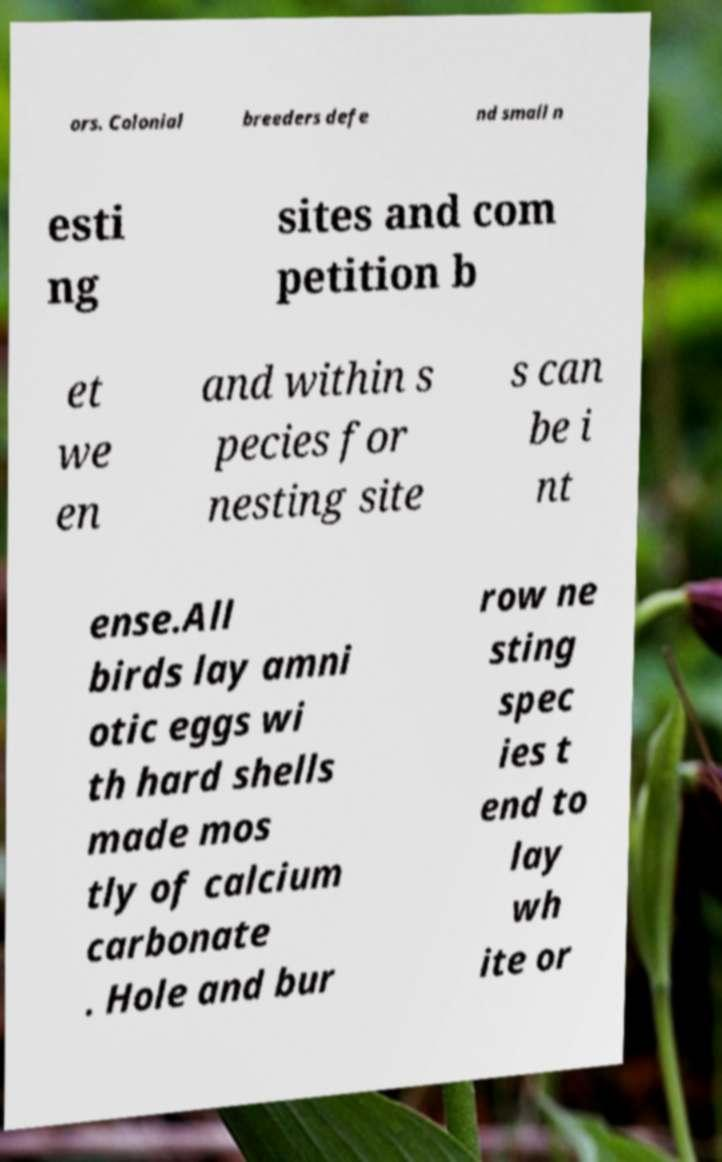Could you assist in decoding the text presented in this image and type it out clearly? ors. Colonial breeders defe nd small n esti ng sites and com petition b et we en and within s pecies for nesting site s can be i nt ense.All birds lay amni otic eggs wi th hard shells made mos tly of calcium carbonate . Hole and bur row ne sting spec ies t end to lay wh ite or 